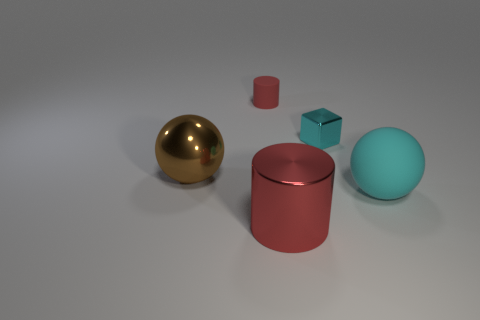Does the big metallic cylinder have the same color as the small cylinder?
Provide a short and direct response. Yes. What size is the cyan rubber sphere?
Give a very brief answer. Large. There is a cylinder in front of the cyan ball; does it have the same size as the large rubber ball?
Give a very brief answer. Yes. The big thing that is left of the red thing that is left of the red object that is in front of the big brown object is what shape?
Your answer should be very brief. Sphere. How many objects are either big cyan balls or large things that are in front of the matte sphere?
Offer a terse response. 2. There is a brown ball that is left of the red metallic object; how big is it?
Keep it short and to the point. Large. What is the shape of the large rubber object that is the same color as the tiny metal object?
Offer a very short reply. Sphere. Are the cube and the large object on the left side of the big red metallic cylinder made of the same material?
Ensure brevity in your answer.  Yes. What number of small cyan metal objects are left of the red thing behind the matte thing that is to the right of the rubber cylinder?
Offer a very short reply. 0. What number of cyan things are either big spheres or small shiny balls?
Your answer should be very brief. 1. 